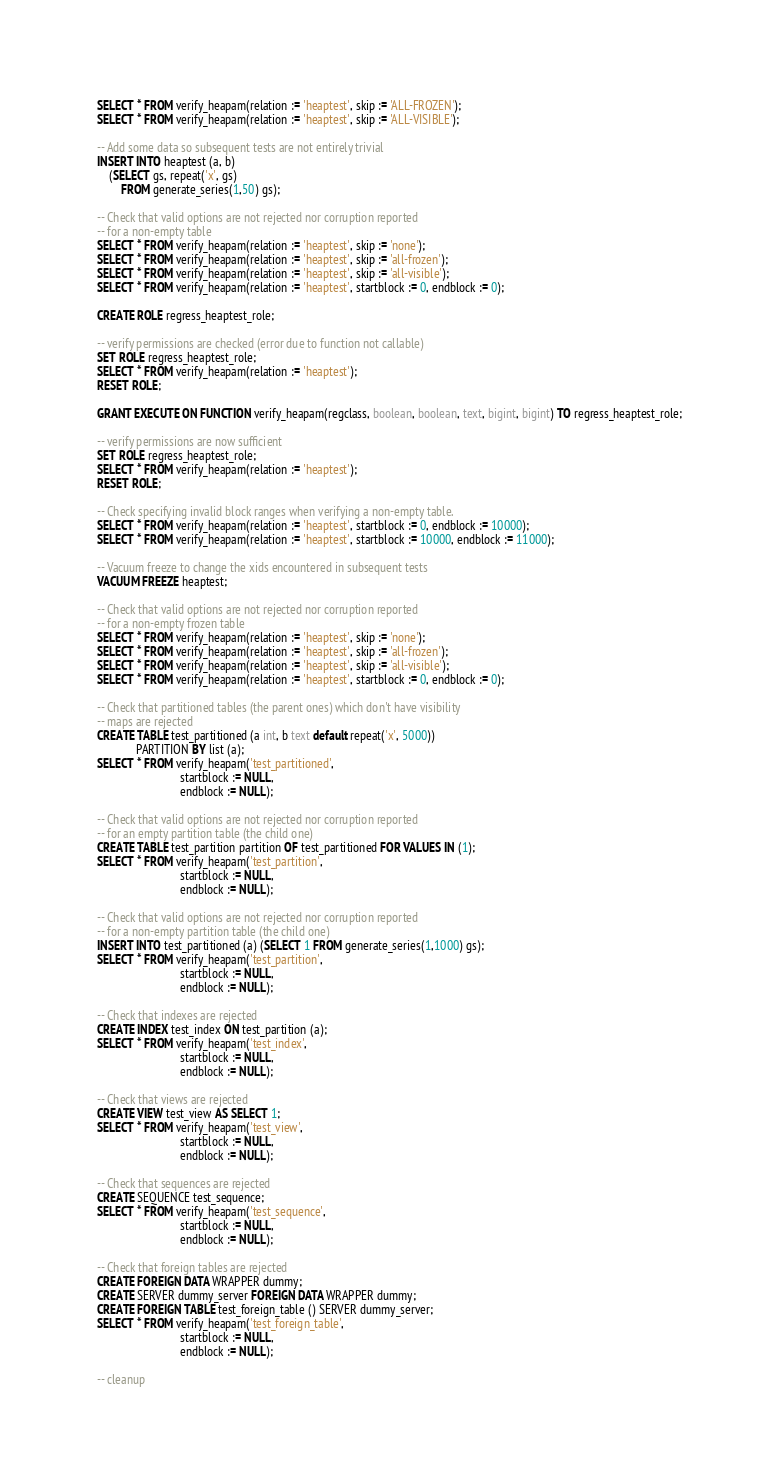Convert code to text. <code><loc_0><loc_0><loc_500><loc_500><_SQL_>SELECT * FROM verify_heapam(relation := 'heaptest', skip := 'ALL-FROZEN');
SELECT * FROM verify_heapam(relation := 'heaptest', skip := 'ALL-VISIBLE');

-- Add some data so subsequent tests are not entirely trivial
INSERT INTO heaptest (a, b)
	(SELECT gs, repeat('x', gs)
		FROM generate_series(1,50) gs);

-- Check that valid options are not rejected nor corruption reported
-- for a non-empty table
SELECT * FROM verify_heapam(relation := 'heaptest', skip := 'none');
SELECT * FROM verify_heapam(relation := 'heaptest', skip := 'all-frozen');
SELECT * FROM verify_heapam(relation := 'heaptest', skip := 'all-visible');
SELECT * FROM verify_heapam(relation := 'heaptest', startblock := 0, endblock := 0);

CREATE ROLE regress_heaptest_role;

-- verify permissions are checked (error due to function not callable)
SET ROLE regress_heaptest_role;
SELECT * FROM verify_heapam(relation := 'heaptest');
RESET ROLE;

GRANT EXECUTE ON FUNCTION verify_heapam(regclass, boolean, boolean, text, bigint, bigint) TO regress_heaptest_role;

-- verify permissions are now sufficient
SET ROLE regress_heaptest_role;
SELECT * FROM verify_heapam(relation := 'heaptest');
RESET ROLE;

-- Check specifying invalid block ranges when verifying a non-empty table.
SELECT * FROM verify_heapam(relation := 'heaptest', startblock := 0, endblock := 10000);
SELECT * FROM verify_heapam(relation := 'heaptest', startblock := 10000, endblock := 11000);

-- Vacuum freeze to change the xids encountered in subsequent tests
VACUUM FREEZE heaptest;

-- Check that valid options are not rejected nor corruption reported
-- for a non-empty frozen table
SELECT * FROM verify_heapam(relation := 'heaptest', skip := 'none');
SELECT * FROM verify_heapam(relation := 'heaptest', skip := 'all-frozen');
SELECT * FROM verify_heapam(relation := 'heaptest', skip := 'all-visible');
SELECT * FROM verify_heapam(relation := 'heaptest', startblock := 0, endblock := 0);

-- Check that partitioned tables (the parent ones) which don't have visibility
-- maps are rejected
CREATE TABLE test_partitioned (a int, b text default repeat('x', 5000))
			 PARTITION BY list (a);
SELECT * FROM verify_heapam('test_partitioned',
							startblock := NULL,
							endblock := NULL);

-- Check that valid options are not rejected nor corruption reported
-- for an empty partition table (the child one)
CREATE TABLE test_partition partition OF test_partitioned FOR VALUES IN (1);
SELECT * FROM verify_heapam('test_partition',
							startblock := NULL,
							endblock := NULL);

-- Check that valid options are not rejected nor corruption reported
-- for a non-empty partition table (the child one)
INSERT INTO test_partitioned (a) (SELECT 1 FROM generate_series(1,1000) gs);
SELECT * FROM verify_heapam('test_partition',
							startblock := NULL,
							endblock := NULL);

-- Check that indexes are rejected
CREATE INDEX test_index ON test_partition (a);
SELECT * FROM verify_heapam('test_index',
							startblock := NULL,
							endblock := NULL);

-- Check that views are rejected
CREATE VIEW test_view AS SELECT 1;
SELECT * FROM verify_heapam('test_view',
							startblock := NULL,
							endblock := NULL);

-- Check that sequences are rejected
CREATE SEQUENCE test_sequence;
SELECT * FROM verify_heapam('test_sequence',
							startblock := NULL,
							endblock := NULL);

-- Check that foreign tables are rejected
CREATE FOREIGN DATA WRAPPER dummy;
CREATE SERVER dummy_server FOREIGN DATA WRAPPER dummy;
CREATE FOREIGN TABLE test_foreign_table () SERVER dummy_server;
SELECT * FROM verify_heapam('test_foreign_table',
							startblock := NULL,
							endblock := NULL);

-- cleanup</code> 